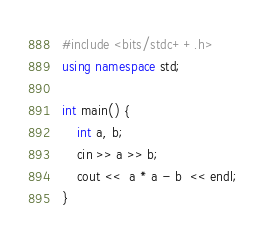Convert code to text. <code><loc_0><loc_0><loc_500><loc_500><_C++_>#include <bits/stdc++.h>
using namespace std;

int main() {
	int a, b;
  	cin >> a >> b;
  	cout <<  a * a - b  << endl;
}</code> 